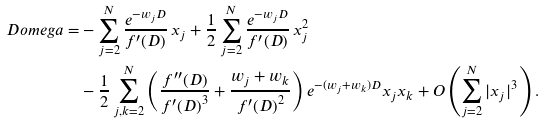<formula> <loc_0><loc_0><loc_500><loc_500>\ D o m e g a = & - \sum _ { j = 2 } ^ { N } \frac { e ^ { - w _ { j } D } } { f ^ { \prime } ( D ) } \, x _ { j } + \frac { 1 } { 2 } \sum _ { j = 2 } ^ { N } \frac { e ^ { - w _ { j } D } } { f ^ { \prime } ( D ) } \, x _ { j } ^ { 2 } \\ & - \frac { 1 } { 2 } \sum _ { j , k = 2 } ^ { N } \left ( \frac { f ^ { \prime \prime } ( D ) } { { f ^ { \prime } ( D ) } ^ { 3 } } + \frac { w _ { j } + w _ { k } } { { f ^ { \prime } ( D ) } ^ { 2 } } \right ) e ^ { - ( w _ { j } + w _ { k } ) D } x _ { j } x _ { k } + O \left ( \sum _ { j = 2 } ^ { N } | x _ { j } | ^ { 3 } \right ) .</formula> 